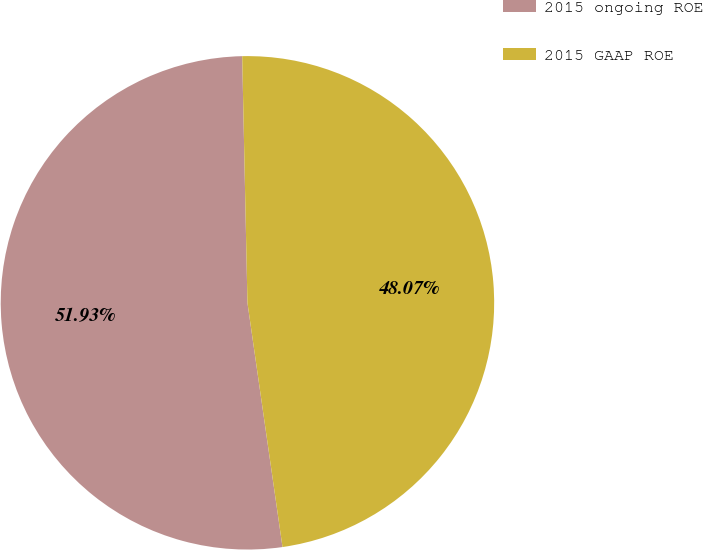<chart> <loc_0><loc_0><loc_500><loc_500><pie_chart><fcel>2015 ongoing ROE<fcel>2015 GAAP ROE<nl><fcel>51.93%<fcel>48.07%<nl></chart> 